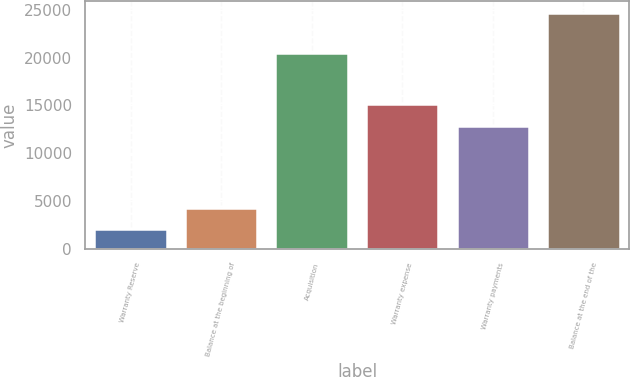Convert chart. <chart><loc_0><loc_0><loc_500><loc_500><bar_chart><fcel>Warranty Reserve<fcel>Balance at the beginning of<fcel>Acquisition<fcel>Warranty expense<fcel>Warranty payments<fcel>Balance at the end of the<nl><fcel>2014<fcel>4279.2<fcel>20501<fcel>15134.2<fcel>12869<fcel>24666<nl></chart> 